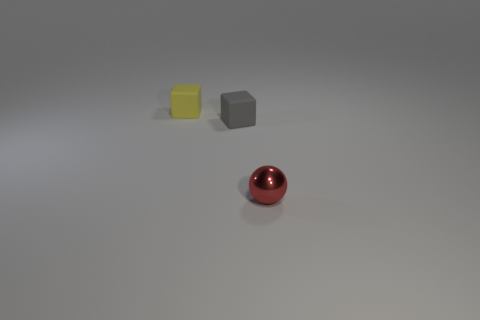Add 3 tiny yellow matte objects. How many objects exist? 6 Subtract all cubes. How many objects are left? 1 Subtract 0 brown cubes. How many objects are left? 3 Subtract all large brown balls. Subtract all tiny gray matte objects. How many objects are left? 2 Add 2 tiny rubber things. How many tiny rubber things are left? 4 Add 3 tiny yellow cubes. How many tiny yellow cubes exist? 4 